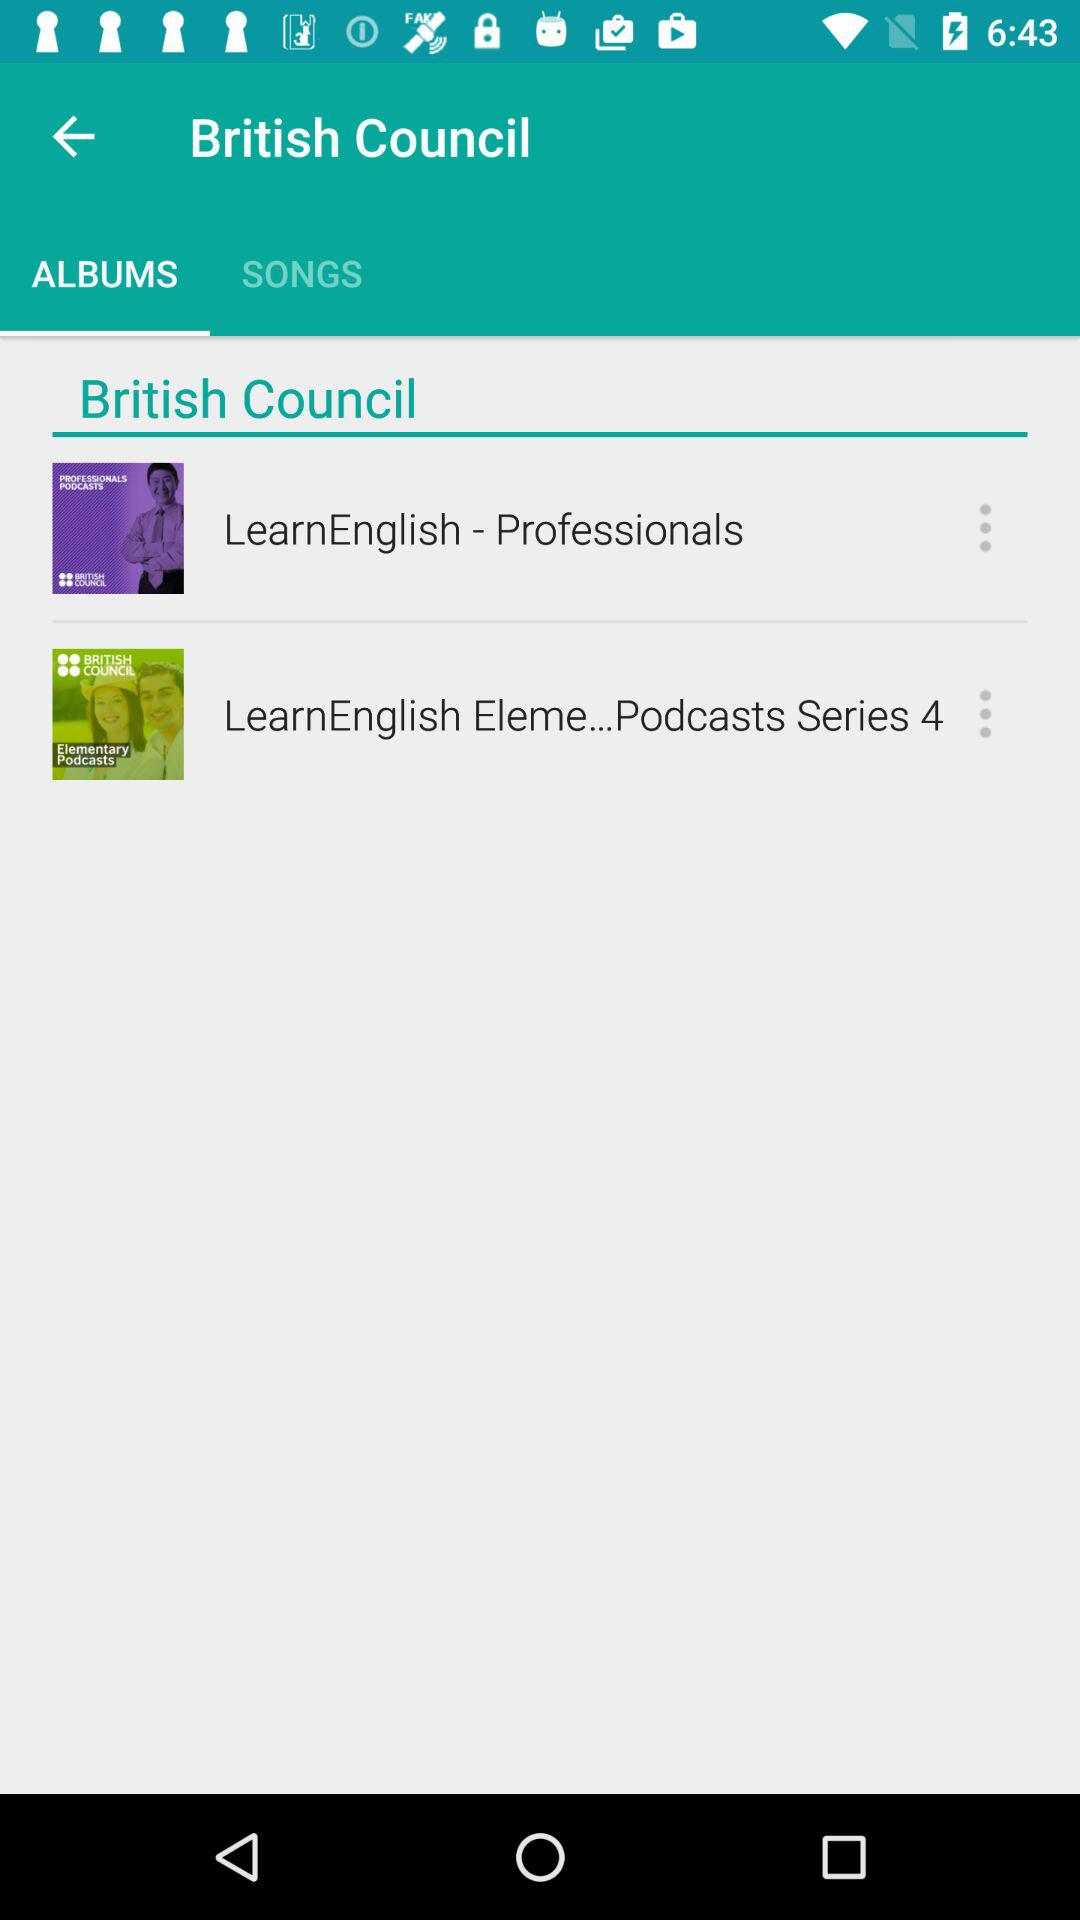What is the name of the album? The names of the albums are "LearnEnglish - Professionals" and "LearnEnglish Eleme...Podcasts Series 4". 